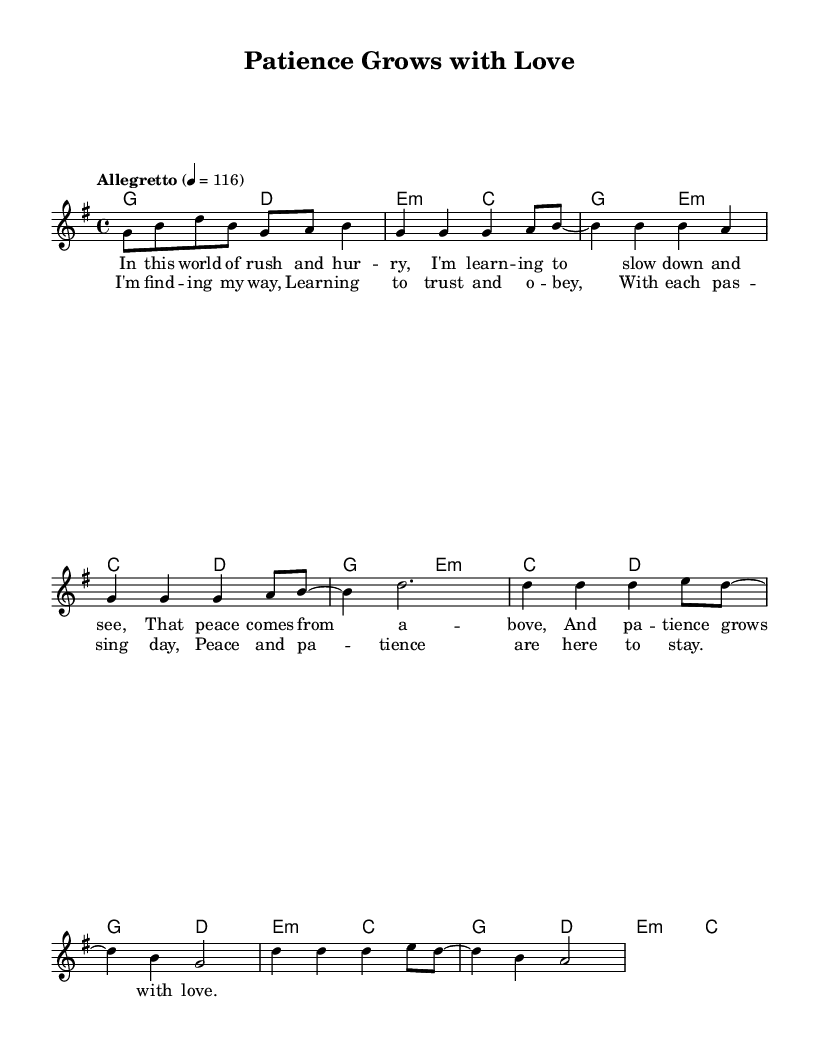What is the key signature of this music? The key signature displayed indicates that the piece is in G major, which has one sharp (F#). You can identify this by looking next to the clef symbol at the beginning of the staff.
Answer: G major What is the time signature of this music? The time signature shown at the beginning of the piece is 4/4, which means there are four beats in a measure and the quarter note gets one beat. This is typically indicated at the start of the score after the key signature.
Answer: 4/4 What is the tempo marking for this piece? The tempo marking states "Allegretto" with a metronome marking of 4 = 116. This suggests a moderately fast tempo, which is noted right after the time signature.
Answer: Allegretto, 116 How many measures are there in the chorus section? To determine the number of measures in the chorus, we count the lines dedicated to the chorus. From the lyrical section labeled as the chorus, there are four measures.
Answer: Four measures What does the phrase "peace comes from above" suggest thematically? The phrase indicates a belief in divine intervention or support for finding peace, which aligns with common themes in religious music. This is derived from analyzing the lyrics that focus on spiritual influences.
Answer: Divine intervention What is the structure of this piece? The structure consists of an introduction, verses, and a chorus. The score layout separates these sections, with the introductory melody, followed by four measures of verse lyrics, and concludes with a chorus.
Answer: Intro, Verse, Chorus What kind of emotions does this song convey based on the lyrics? The lyrics express feelings of tranquility, trust, and a developing sense of patience, reflecting positive emotions. This is inferred from the uplifting message contained within the verses and chorus, which emphasize growth through love and patience.
Answer: Tranquility, trust, patience 